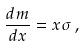<formula> <loc_0><loc_0><loc_500><loc_500>\frac { d m } { d x } = x \sigma \, ,</formula> 